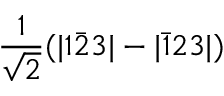Convert formula to latex. <formula><loc_0><loc_0><loc_500><loc_500>\frac { 1 } { \sqrt { 2 } } ( | 1 \bar { 2 } 3 | - | \bar { 1 } 2 3 | )</formula> 